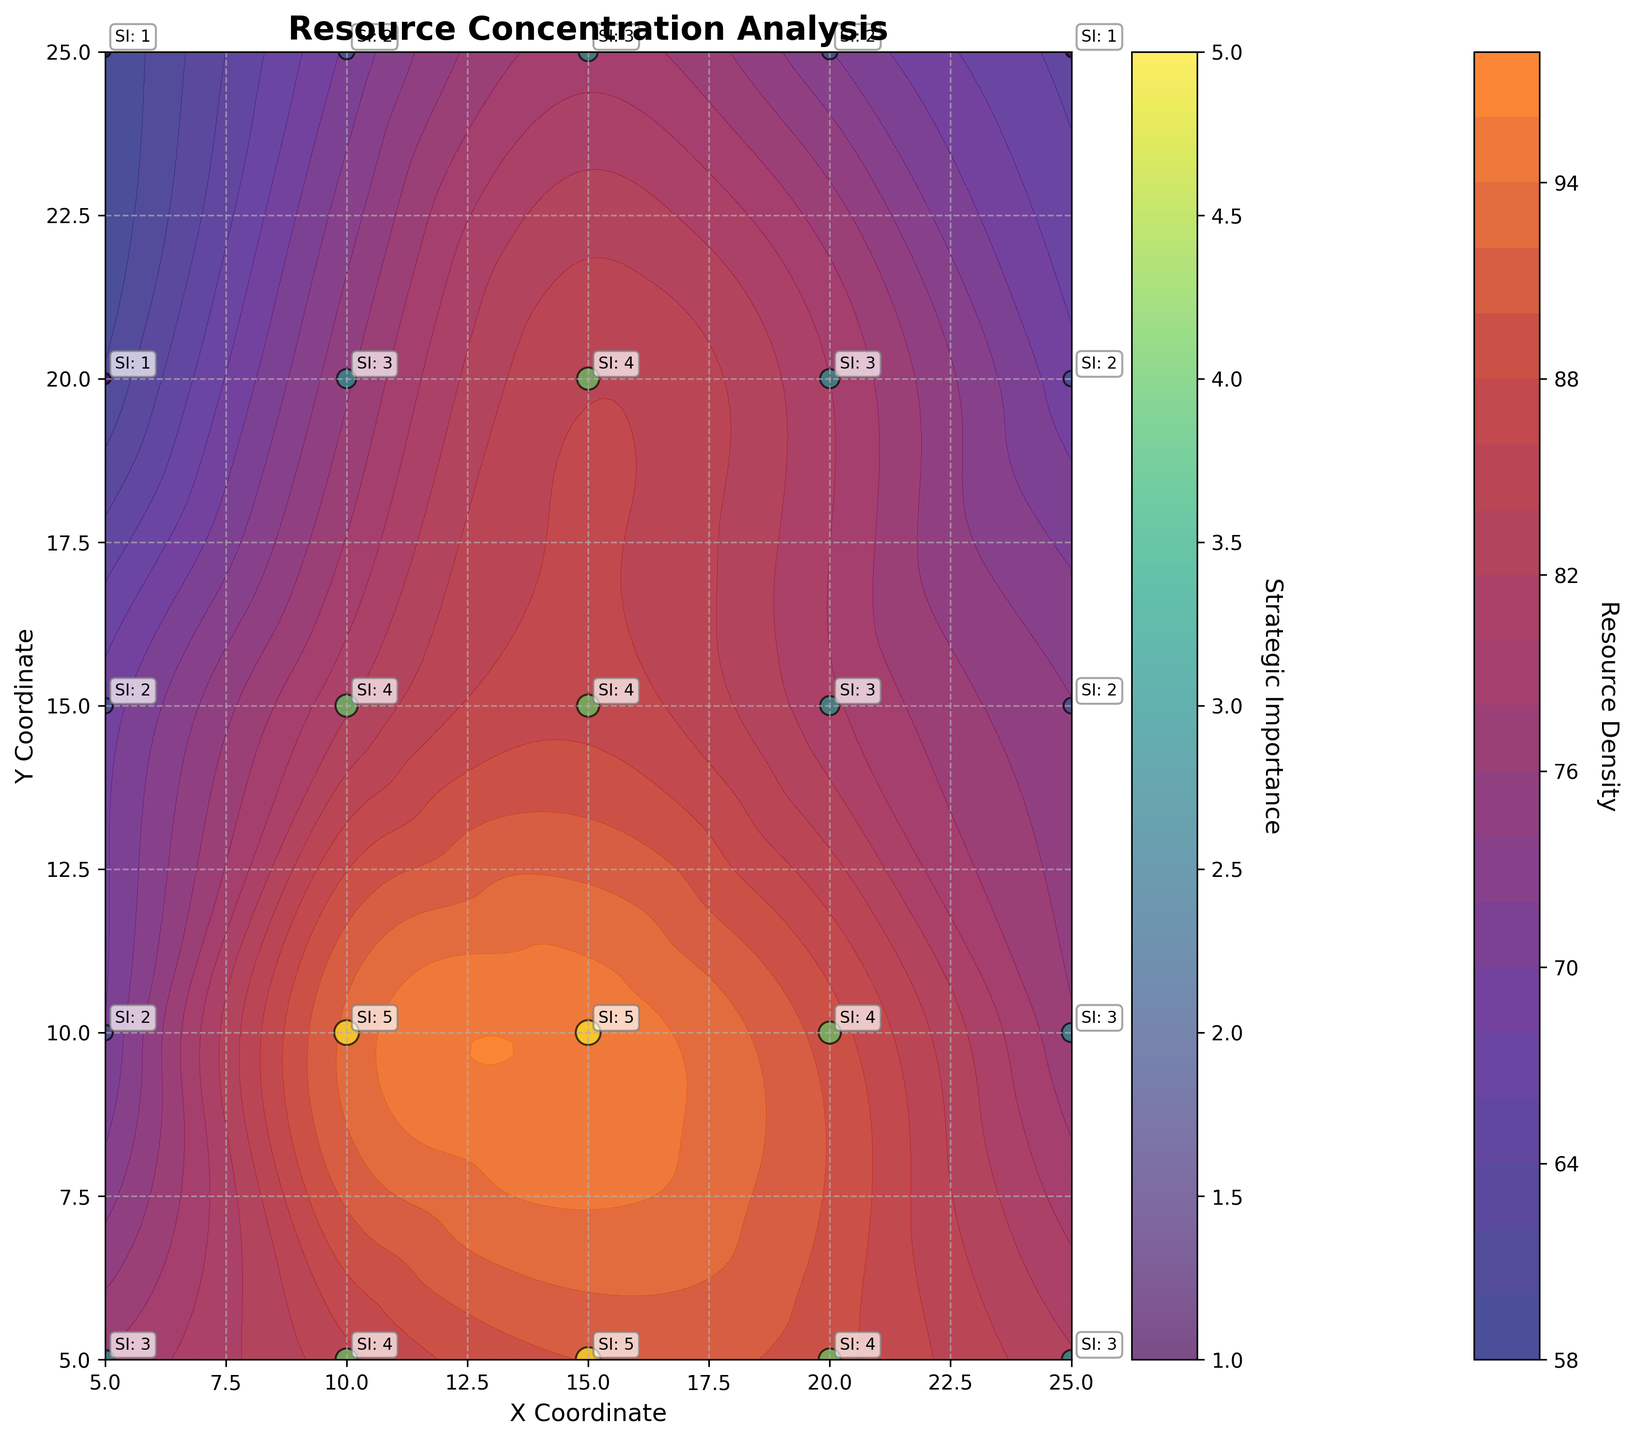What is the title of the figure? The title of the figure is located at the top of the plot, indicating the main topic or focus of the visual representation. In this case, it describes the analysis being presented.
Answer: Resource Concentration Analysis Which coordinates have the highest resource density based on the contour plot? By examining the contour plot, we can identify the coordinates with the highest resource density by finding the darkest or most intense colors indicated by the color scale representing high values.
Answer: (15, 10) How is resource density visually represented in the plot? Resource density is illustrated using a color gradient, where different shades indicate varying levels of density. The color bar on the side provides a legend for these values, and the contour lines help show areas of equal density.
Answer: Color gradient and contour lines What is the strategic importance value for the coordinate (15, 10)? To find the strategic importance value for this specific coordinate, locate it on the scatter plot and read the annotated value or refer to the legend that uses a color scale to denote strategic importance.
Answer: 5 Which X coordinate has the most variation in resource density across different Y coordinates? Comparing the contours and variations in color intensity along each X coordinate can reveal which one shows the most change. Identify the X coordinate with the most diverse range of density values.
Answer: X = 10 What is the range of resource density values shown on the color bar? The color bar on the side of the contour plot provides a scale for resource density, showing the minimum and maximum values represented in the plot's color gradient.
Answer: Approximately 58 to 95 Which areas of the map are indicated to have low strategic importance? Areas with low strategic importance can be identified by their corresponding lighter or less intense scatter plot colors and smaller bubble sizes, as indicated by the strategic importance legend.
Answer: (5, 20); (5, 25); (25, 25) Compare the resource density between coordinates (5, 5) and (25, 5). Which is higher? Look at the contour plot colors and potentially the specific values if visible for these coordinates. By comparing the shades, higher density will correspond to a darker color.
Answer: (25, 5) What general relationship can be observed between resource density and strategic importance? By observing the scatter plot overlay on the contour plot, it becomes clear if areas with higher resource density also have higher strategic importance, given the color and size of scatter points.
Answer: Higher resource density often correlates with higher strategic importance In which region (quadrant) of the plot do you find the highest concentration of resources? Analyzing the color intensity and contour lines across the four quadrants (top-left, top-right, bottom-left, bottom-right), the region with the darkest and most concentrated colors represents the highest resource density.
Answer: Top Right (quadrant containing (15, 10)) 